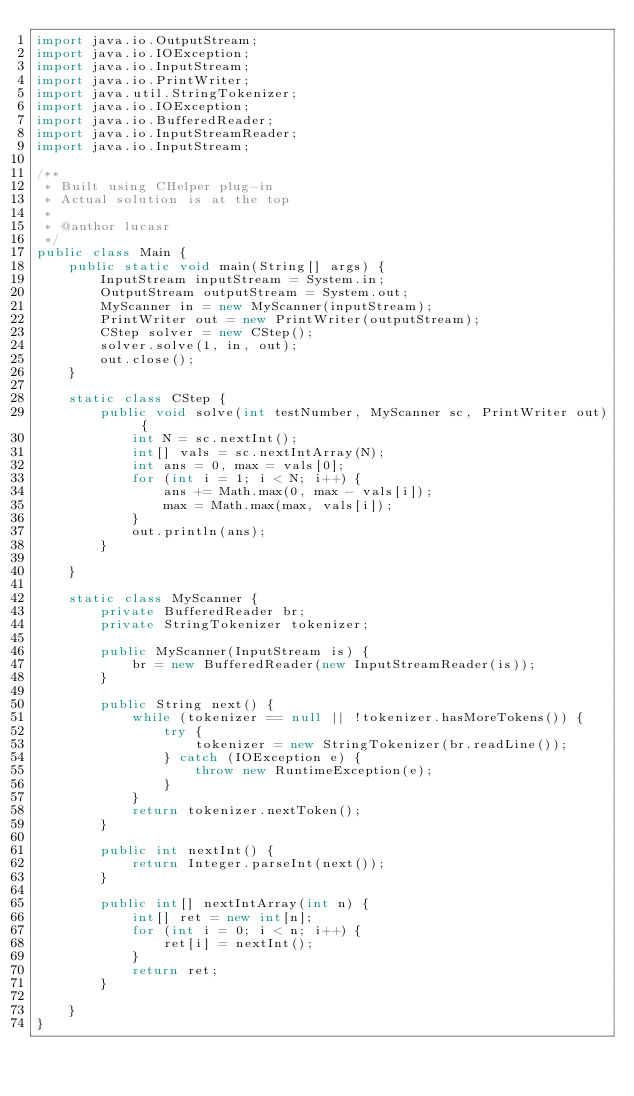<code> <loc_0><loc_0><loc_500><loc_500><_Java_>import java.io.OutputStream;
import java.io.IOException;
import java.io.InputStream;
import java.io.PrintWriter;
import java.util.StringTokenizer;
import java.io.IOException;
import java.io.BufferedReader;
import java.io.InputStreamReader;
import java.io.InputStream;

/**
 * Built using CHelper plug-in
 * Actual solution is at the top
 *
 * @author lucasr
 */
public class Main {
    public static void main(String[] args) {
        InputStream inputStream = System.in;
        OutputStream outputStream = System.out;
        MyScanner in = new MyScanner(inputStream);
        PrintWriter out = new PrintWriter(outputStream);
        CStep solver = new CStep();
        solver.solve(1, in, out);
        out.close();
    }

    static class CStep {
        public void solve(int testNumber, MyScanner sc, PrintWriter out) {
            int N = sc.nextInt();
            int[] vals = sc.nextIntArray(N);
            int ans = 0, max = vals[0];
            for (int i = 1; i < N; i++) {
                ans += Math.max(0, max - vals[i]);
                max = Math.max(max, vals[i]);
            }
            out.println(ans);
        }

    }

    static class MyScanner {
        private BufferedReader br;
        private StringTokenizer tokenizer;

        public MyScanner(InputStream is) {
            br = new BufferedReader(new InputStreamReader(is));
        }

        public String next() {
            while (tokenizer == null || !tokenizer.hasMoreTokens()) {
                try {
                    tokenizer = new StringTokenizer(br.readLine());
                } catch (IOException e) {
                    throw new RuntimeException(e);
                }
            }
            return tokenizer.nextToken();
        }

        public int nextInt() {
            return Integer.parseInt(next());
        }

        public int[] nextIntArray(int n) {
            int[] ret = new int[n];
            for (int i = 0; i < n; i++) {
                ret[i] = nextInt();
            }
            return ret;
        }

    }
}

</code> 